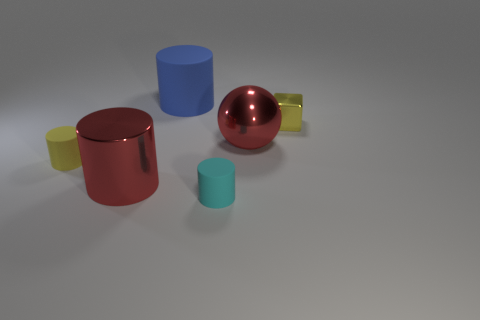What is the color of the tiny block?
Provide a short and direct response. Yellow. Are there any tiny rubber objects that have the same color as the large metallic sphere?
Offer a terse response. No. There is a large cylinder that is in front of the red metal sphere; does it have the same color as the ball?
Your response must be concise. Yes. How many things are matte things that are in front of the tiny shiny object or small yellow blocks?
Ensure brevity in your answer.  3. Are there any large red metal things to the right of the small block?
Provide a succinct answer. No. There is a ball that is the same color as the metal cylinder; what is its material?
Ensure brevity in your answer.  Metal. Is the material of the big thing that is behind the tiny yellow cube the same as the cyan cylinder?
Offer a terse response. Yes. There is a large red metal thing to the right of the thing that is behind the metal block; is there a large blue cylinder that is right of it?
Make the answer very short. No. How many cubes are either tiny brown metal objects or large blue rubber objects?
Your answer should be compact. 0. There is a small yellow object that is on the left side of the small cube; what is its material?
Make the answer very short. Rubber. 